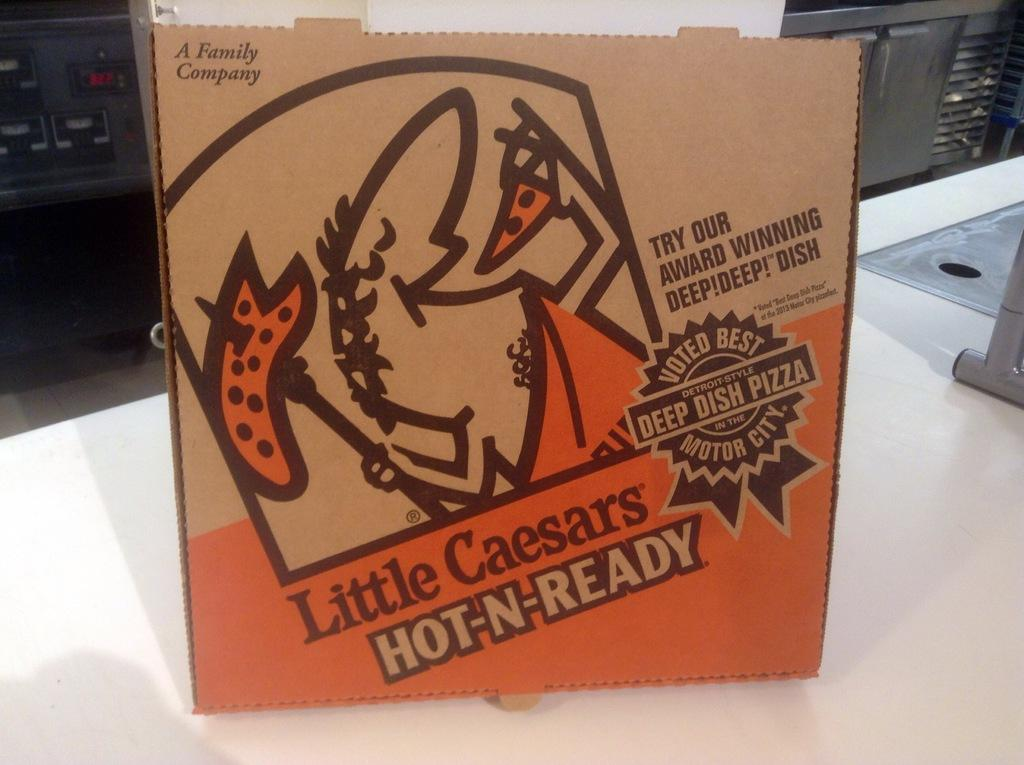Provide a one-sentence caption for the provided image. The pizza in this box is described as award winning and voted best. 